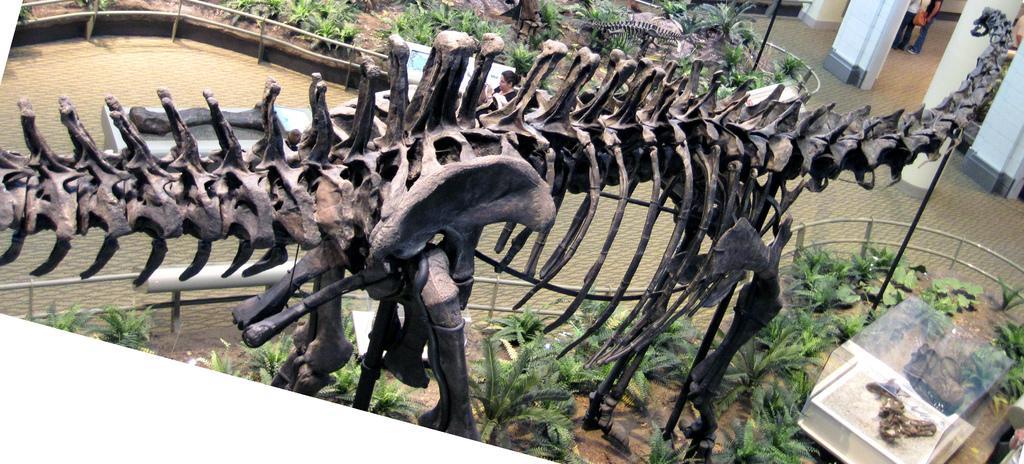Please provide a concise description of this image. In this image we can see a skeleton of an animal and we can also see plants, railing, pillars and people. 